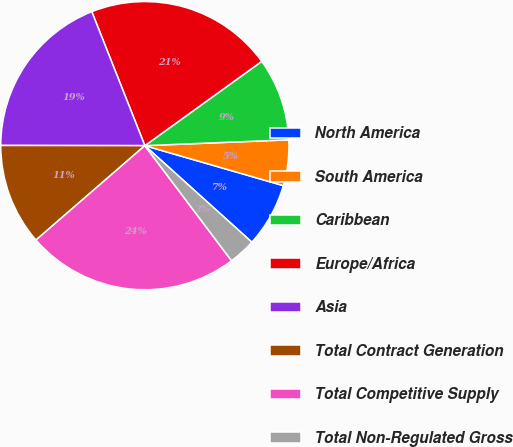<chart> <loc_0><loc_0><loc_500><loc_500><pie_chart><fcel>North America<fcel>South America<fcel>Caribbean<fcel>Europe/Africa<fcel>Asia<fcel>Total Contract Generation<fcel>Total Competitive Supply<fcel>Total Non-Regulated Gross<nl><fcel>7.21%<fcel>5.12%<fcel>9.3%<fcel>21.06%<fcel>18.98%<fcel>11.39%<fcel>23.91%<fcel>3.04%<nl></chart> 